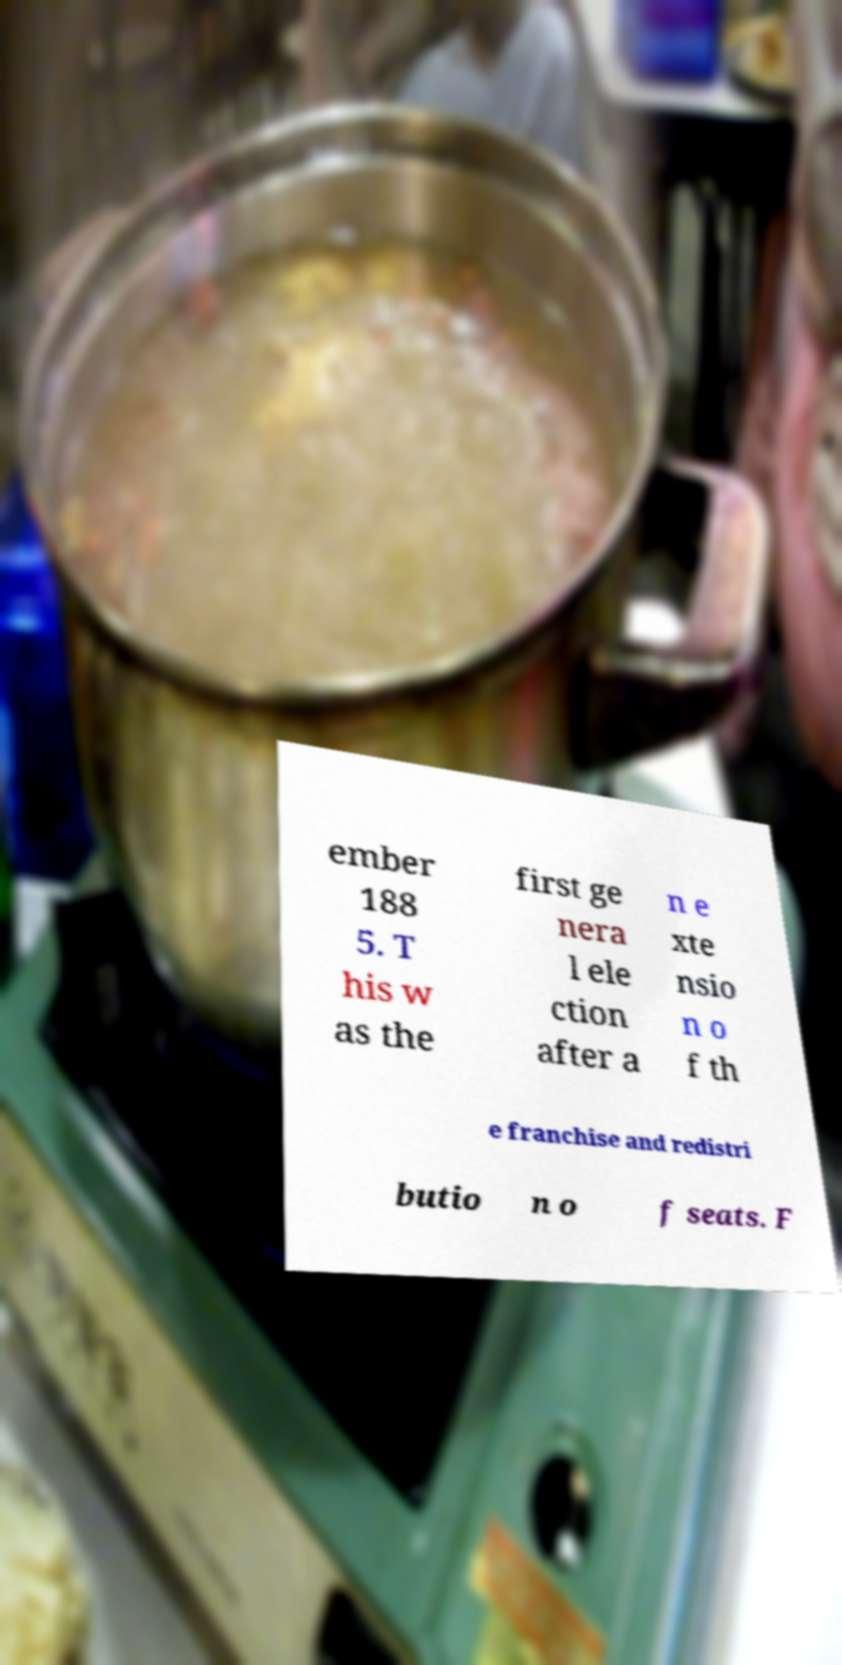Can you accurately transcribe the text from the provided image for me? ember 188 5. T his w as the first ge nera l ele ction after a n e xte nsio n o f th e franchise and redistri butio n o f seats. F 